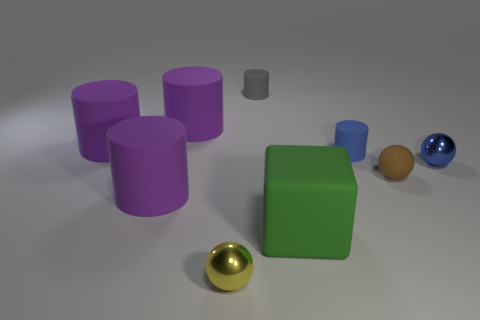There is a small thing behind the blue cylinder behind the brown thing; are there any small gray cylinders that are to the left of it?
Your response must be concise. No. What is the color of the large rubber block?
Your answer should be very brief. Green. The rubber cylinder that is the same size as the gray thing is what color?
Your answer should be compact. Blue. There is a metal thing that is to the right of the big matte block; is it the same shape as the brown thing?
Offer a very short reply. Yes. The big matte cylinder to the left of the big cylinder in front of the tiny metal sphere right of the small gray matte object is what color?
Make the answer very short. Purple. Are any tiny blue objects visible?
Ensure brevity in your answer.  Yes. What number of other things are the same size as the yellow ball?
Your answer should be compact. 4. There is a matte sphere; is it the same color as the metal thing that is right of the small blue matte cylinder?
Your response must be concise. No. What number of objects are either small blue cylinders or large green blocks?
Your answer should be compact. 2. Is there any other thing that is the same color as the big rubber cube?
Your answer should be very brief. No. 